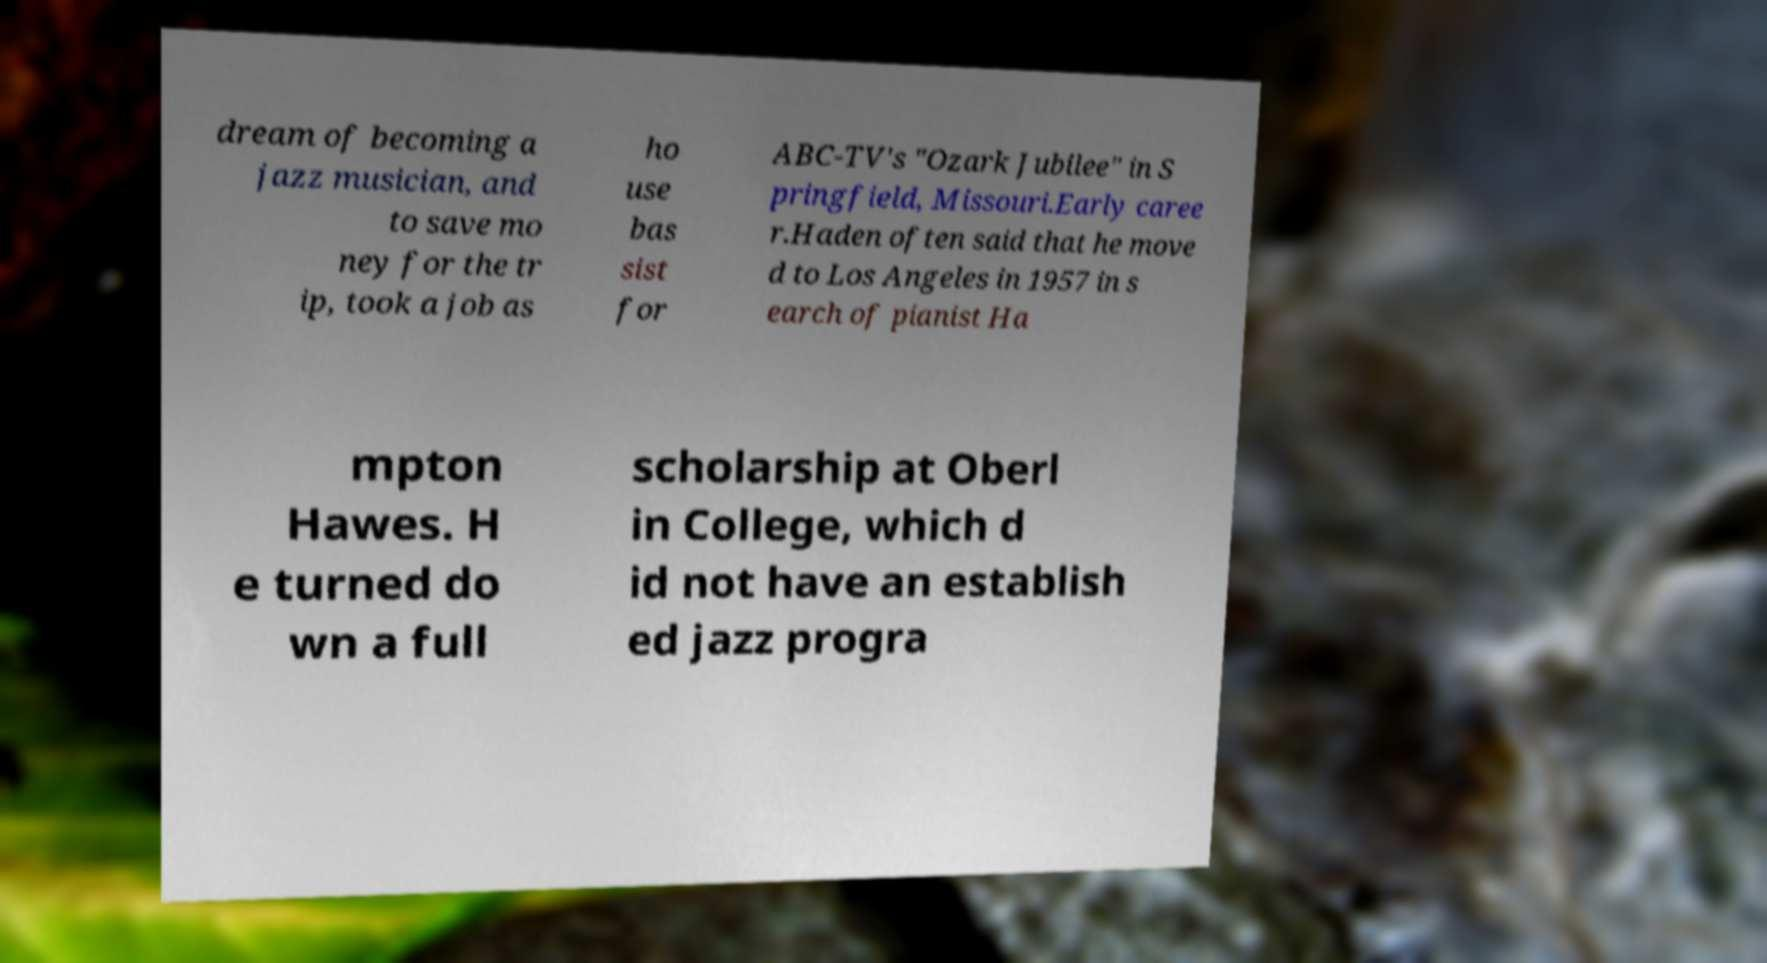Please identify and transcribe the text found in this image. dream of becoming a jazz musician, and to save mo ney for the tr ip, took a job as ho use bas sist for ABC-TV's "Ozark Jubilee" in S pringfield, Missouri.Early caree r.Haden often said that he move d to Los Angeles in 1957 in s earch of pianist Ha mpton Hawes. H e turned do wn a full scholarship at Oberl in College, which d id not have an establish ed jazz progra 